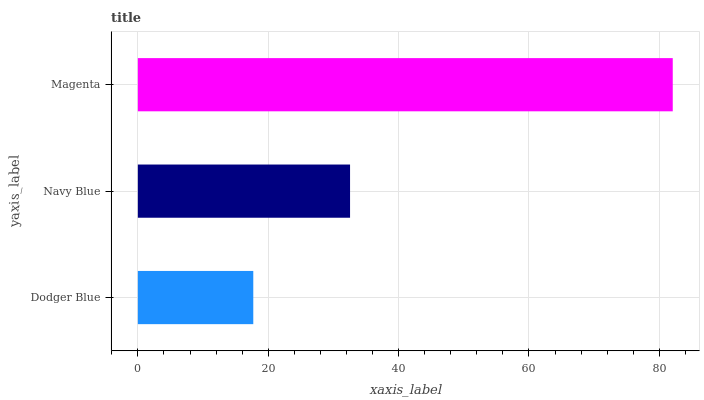Is Dodger Blue the minimum?
Answer yes or no. Yes. Is Magenta the maximum?
Answer yes or no. Yes. Is Navy Blue the minimum?
Answer yes or no. No. Is Navy Blue the maximum?
Answer yes or no. No. Is Navy Blue greater than Dodger Blue?
Answer yes or no. Yes. Is Dodger Blue less than Navy Blue?
Answer yes or no. Yes. Is Dodger Blue greater than Navy Blue?
Answer yes or no. No. Is Navy Blue less than Dodger Blue?
Answer yes or no. No. Is Navy Blue the high median?
Answer yes or no. Yes. Is Navy Blue the low median?
Answer yes or no. Yes. Is Magenta the high median?
Answer yes or no. No. Is Dodger Blue the low median?
Answer yes or no. No. 